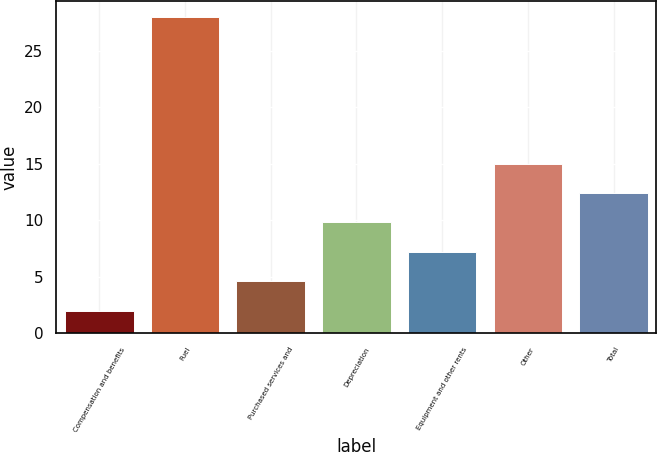<chart> <loc_0><loc_0><loc_500><loc_500><bar_chart><fcel>Compensation and benefits<fcel>Fuel<fcel>Purchased services and<fcel>Depreciation<fcel>Equipment and other rents<fcel>Other<fcel>Total<nl><fcel>2<fcel>28<fcel>4.6<fcel>9.8<fcel>7.2<fcel>15<fcel>12.4<nl></chart> 